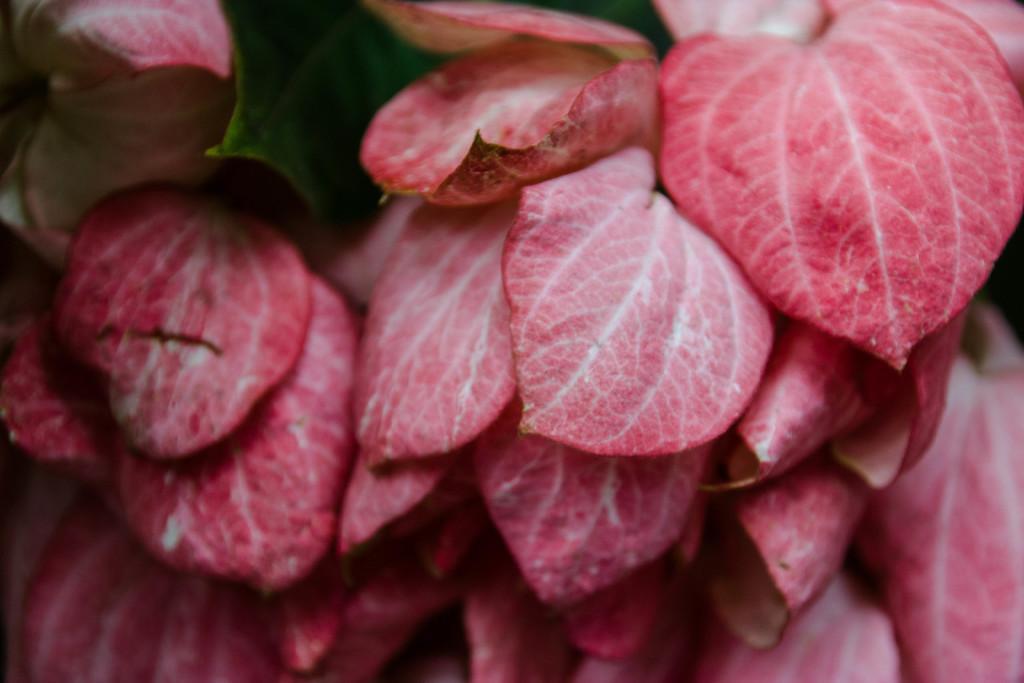Describe this image in one or two sentences. In the picture we can see a group of leaves which are red in color and in the middle of it, we can see a part of green color leaf. 